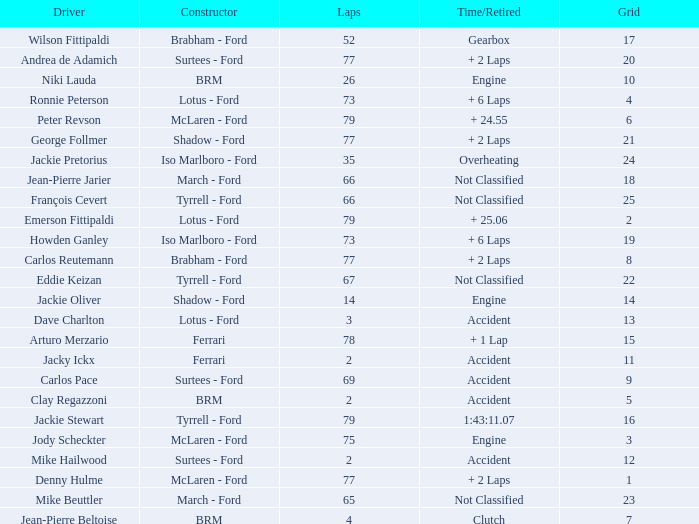How much time is required for less than 35 laps and less than 10 grids? Clutch, Accident. Can you parse all the data within this table? {'header': ['Driver', 'Constructor', 'Laps', 'Time/Retired', 'Grid'], 'rows': [['Wilson Fittipaldi', 'Brabham - Ford', '52', 'Gearbox', '17'], ['Andrea de Adamich', 'Surtees - Ford', '77', '+ 2 Laps', '20'], ['Niki Lauda', 'BRM', '26', 'Engine', '10'], ['Ronnie Peterson', 'Lotus - Ford', '73', '+ 6 Laps', '4'], ['Peter Revson', 'McLaren - Ford', '79', '+ 24.55', '6'], ['George Follmer', 'Shadow - Ford', '77', '+ 2 Laps', '21'], ['Jackie Pretorius', 'Iso Marlboro - Ford', '35', 'Overheating', '24'], ['Jean-Pierre Jarier', 'March - Ford', '66', 'Not Classified', '18'], ['François Cevert', 'Tyrrell - Ford', '66', 'Not Classified', '25'], ['Emerson Fittipaldi', 'Lotus - Ford', '79', '+ 25.06', '2'], ['Howden Ganley', 'Iso Marlboro - Ford', '73', '+ 6 Laps', '19'], ['Carlos Reutemann', 'Brabham - Ford', '77', '+ 2 Laps', '8'], ['Eddie Keizan', 'Tyrrell - Ford', '67', 'Not Classified', '22'], ['Jackie Oliver', 'Shadow - Ford', '14', 'Engine', '14'], ['Dave Charlton', 'Lotus - Ford', '3', 'Accident', '13'], ['Arturo Merzario', 'Ferrari', '78', '+ 1 Lap', '15'], ['Jacky Ickx', 'Ferrari', '2', 'Accident', '11'], ['Carlos Pace', 'Surtees - Ford', '69', 'Accident', '9'], ['Clay Regazzoni', 'BRM', '2', 'Accident', '5'], ['Jackie Stewart', 'Tyrrell - Ford', '79', '1:43:11.07', '16'], ['Jody Scheckter', 'McLaren - Ford', '75', 'Engine', '3'], ['Mike Hailwood', 'Surtees - Ford', '2', 'Accident', '12'], ['Denny Hulme', 'McLaren - Ford', '77', '+ 2 Laps', '1'], ['Mike Beuttler', 'March - Ford', '65', 'Not Classified', '23'], ['Jean-Pierre Beltoise', 'BRM', '4', 'Clutch', '7']]} 